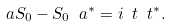<formula> <loc_0><loc_0><loc_500><loc_500>\ a S _ { 0 } - S _ { 0 } \ a ^ { * } = i \ t \ t ^ { * } .</formula> 